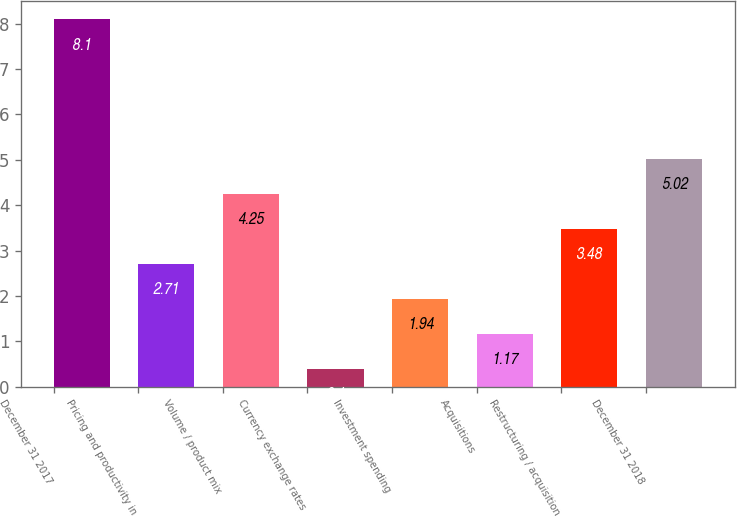Convert chart to OTSL. <chart><loc_0><loc_0><loc_500><loc_500><bar_chart><fcel>December 31 2017<fcel>Pricing and productivity in<fcel>Volume / product mix<fcel>Currency exchange rates<fcel>Investment spending<fcel>Acquisitions<fcel>Restructuring / acquisition<fcel>December 31 2018<nl><fcel>8.1<fcel>2.71<fcel>4.25<fcel>0.4<fcel>1.94<fcel>1.17<fcel>3.48<fcel>5.02<nl></chart> 